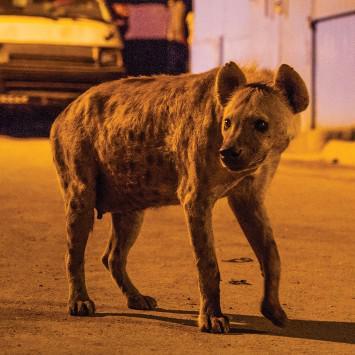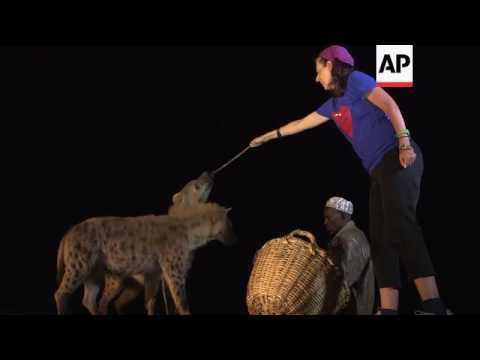The first image is the image on the left, the second image is the image on the right. Evaluate the accuracy of this statement regarding the images: "There are two hyenas in total.". Is it true? Answer yes or no. No. The first image is the image on the left, the second image is the image on the right. Evaluate the accuracy of this statement regarding the images: "The left image contains a human interacting with a hyena.". Is it true? Answer yes or no. No. 